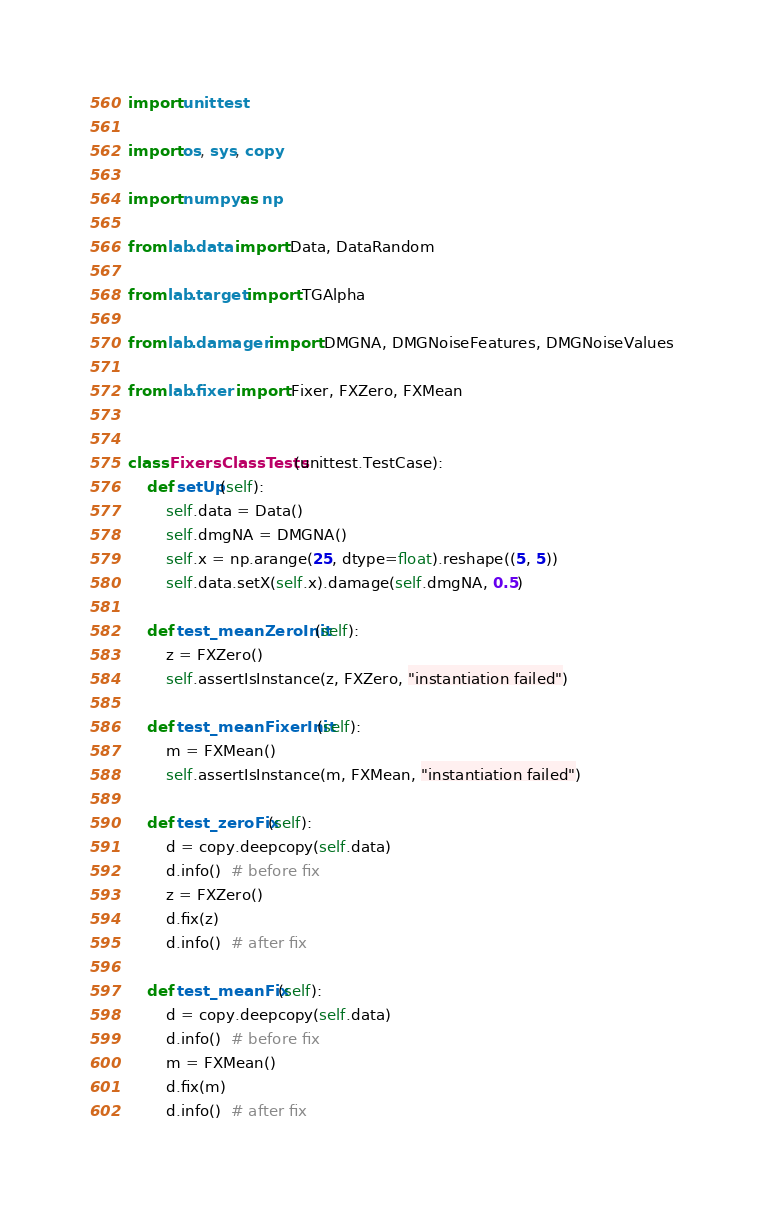Convert code to text. <code><loc_0><loc_0><loc_500><loc_500><_Python_>import unittest

import os, sys, copy

import numpy as np

from lab.data import Data, DataRandom

from lab.target import TGAlpha

from lab.damager import DMGNA, DMGNoiseFeatures, DMGNoiseValues

from lab.fixer import Fixer, FXZero, FXMean


class FixersClassTests(unittest.TestCase):
    def setUp(self):
        self.data = Data()
        self.dmgNA = DMGNA()
        self.x = np.arange(25, dtype=float).reshape((5, 5))
        self.data.setX(self.x).damage(self.dmgNA, 0.5)

    def test_meanZeroInit(self):
        z = FXZero()
        self.assertIsInstance(z, FXZero, "instantiation failed")

    def test_meanFixerInit(self):
        m = FXMean()
        self.assertIsInstance(m, FXMean, "instantiation failed")

    def test_zeroFix(self):
        d = copy.deepcopy(self.data)
        d.info()  # before fix
        z = FXZero()
        d.fix(z)
        d.info()  # after fix

    def test_meanFix(self):
        d = copy.deepcopy(self.data)
        d.info()  # before fix
        m = FXMean()
        d.fix(m)
        d.info()  # after fix
</code> 